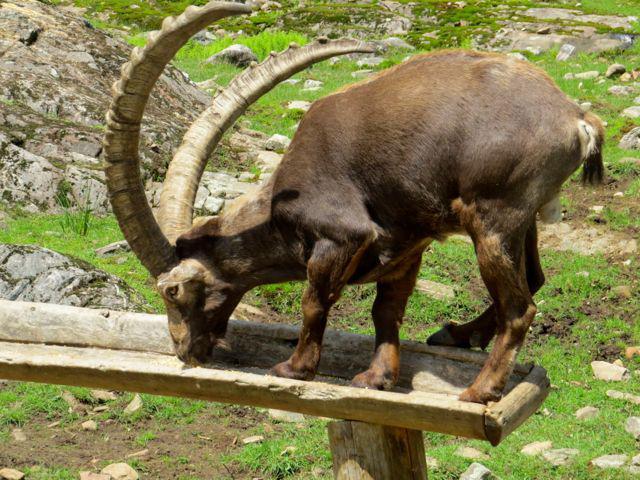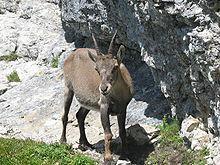The first image is the image on the left, the second image is the image on the right. Analyze the images presented: Is the assertion "a single Ibex is eating grass" valid? Answer yes or no. No. The first image is the image on the left, the second image is the image on the right. Considering the images on both sides, is "Each ram on the left has it's nose down sniffing an object." valid? Answer yes or no. Yes. 